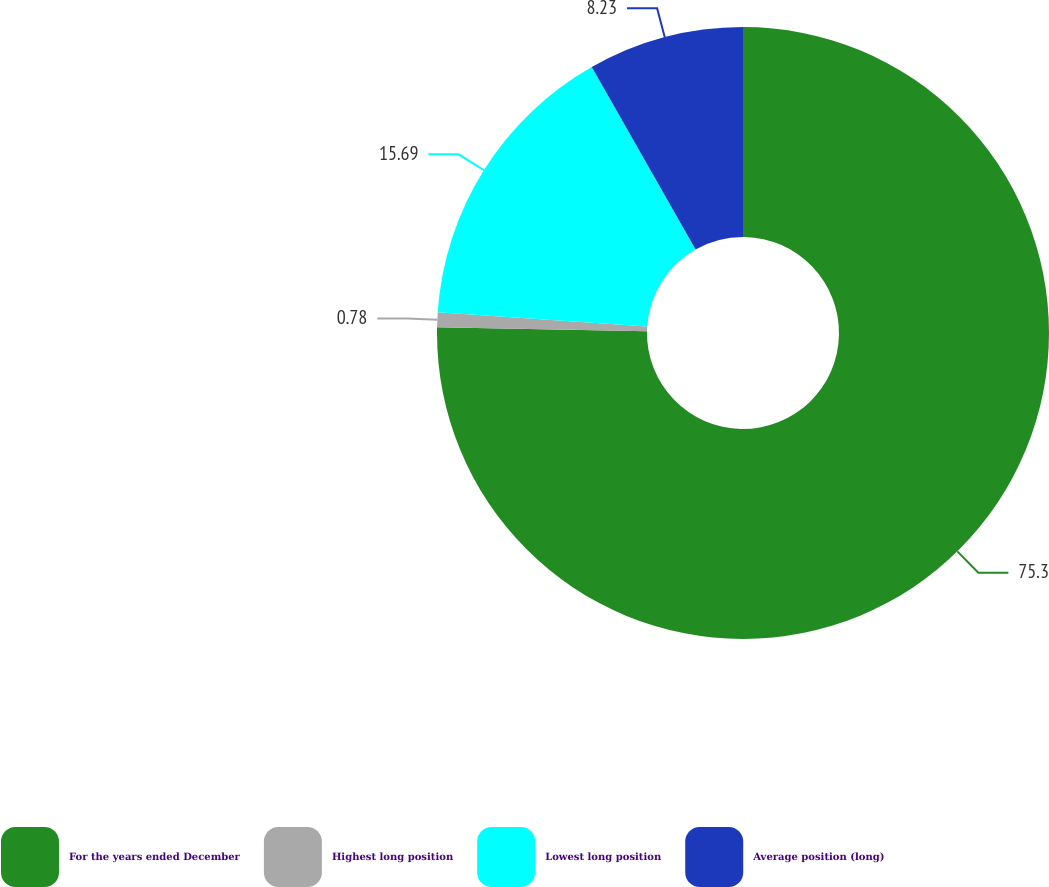Convert chart to OTSL. <chart><loc_0><loc_0><loc_500><loc_500><pie_chart><fcel>For the years ended December<fcel>Highest long position<fcel>Lowest long position<fcel>Average position (long)<nl><fcel>75.3%<fcel>0.78%<fcel>15.69%<fcel>8.23%<nl></chart> 